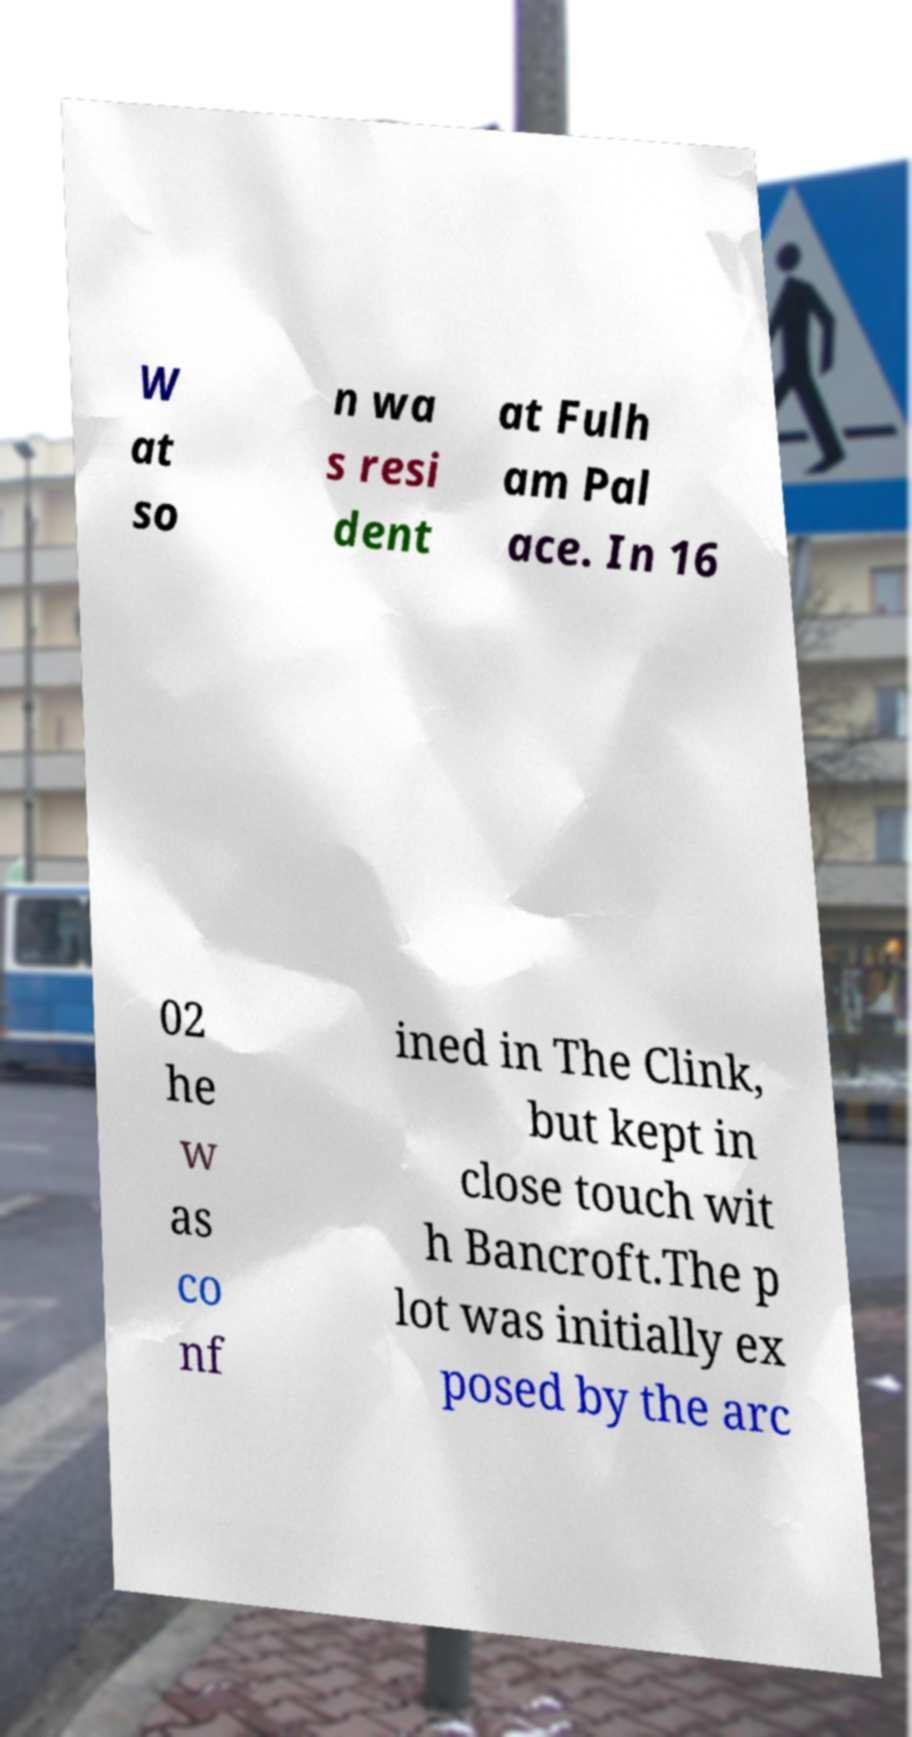There's text embedded in this image that I need extracted. Can you transcribe it verbatim? W at so n wa s resi dent at Fulh am Pal ace. In 16 02 he w as co nf ined in The Clink, but kept in close touch wit h Bancroft.The p lot was initially ex posed by the arc 